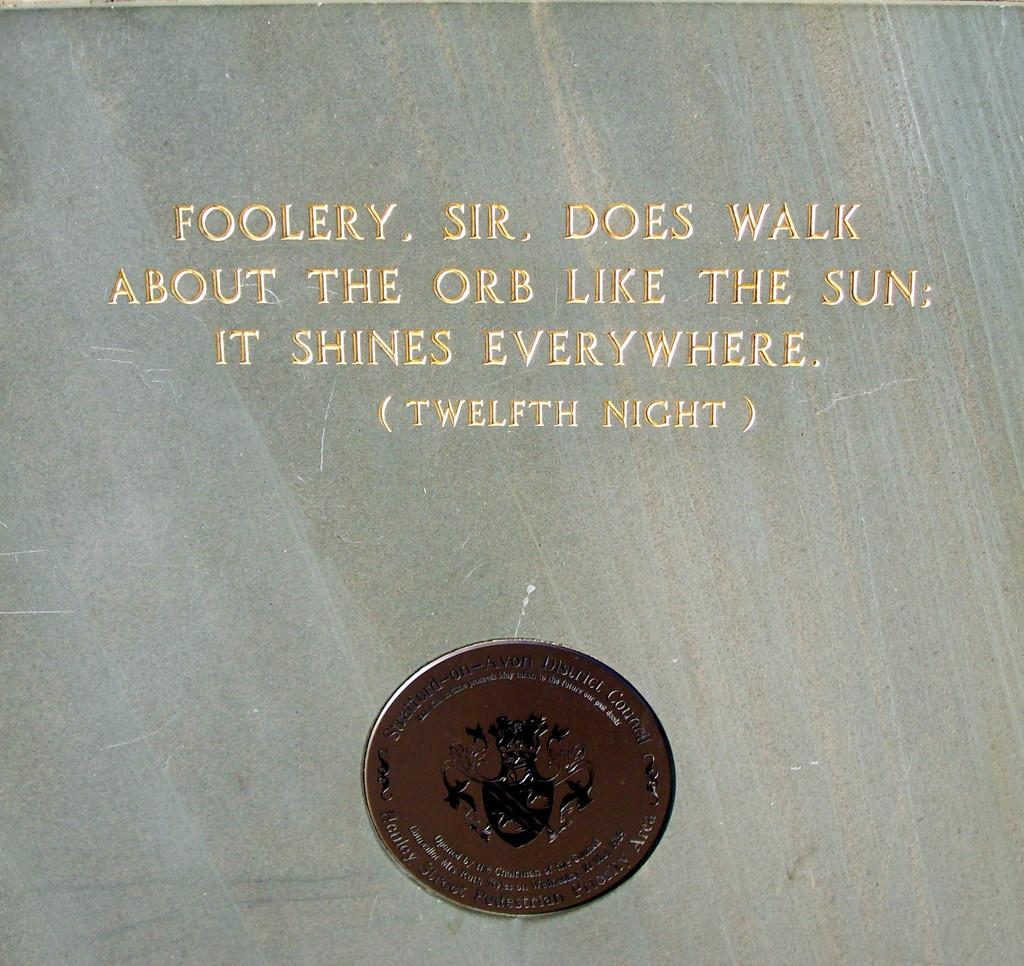<image>
Share a concise interpretation of the image provided. A Twelfth Night quote is inscribed on a stone surface. 